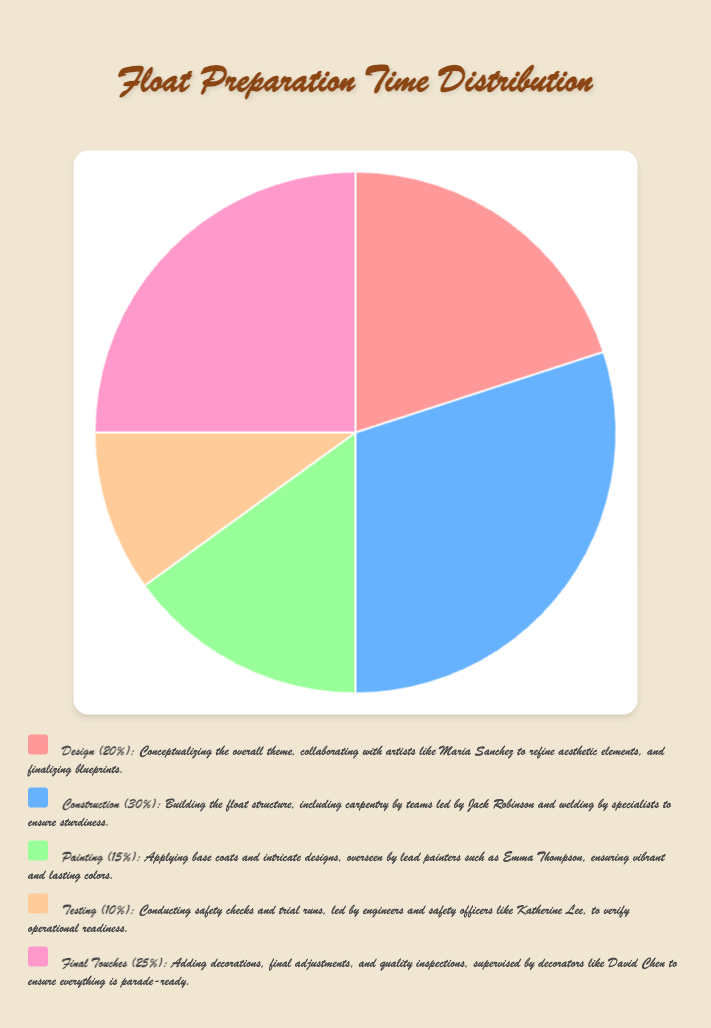What percentage of the total time is spent on Design and Final Touches combined? To get the combined percentage for Design and Final Touches, add their individual percentages: Design (20%) + Final Touches (25%). Therefore, the total is 20 + 25 = 45%.
Answer: 45% Which stage takes up the least amount of time? The stage with the lowest percentage is Testing, which accounts for 10% of the total time spent.
Answer: Testing How does the time spent on Painting compare to Testing? The percentage of time spent on Painting is 15%, while Testing takes up 10%. Painting takes more time than Testing.
Answer: Painting takes more time What is the difference in time spent between Construction and Final Touches? Construction takes 30% of the time, and Final Touches take 25%. The difference is 30 - 25 = 5%.
Answer: 5% If the total time spent on float preparation is 100 hours, how many hours are allocated to Construction? Construction takes up 30% of the total time. Therefore, it is 30% of 100 hours, which is (30/100) * 100 = 30 hours.
Answer: 30 hours What are the stages represented by the pink and blue sections in the pie chart? The pink section represents Design, and the blue section represents Construction.
Answer: Design and Construction How much more time is allocated to Design than Testing? Design takes 20% of the time, while Testing takes 10%. The difference is 20 - 10 = 10%.
Answer: 10% What is the average percentage of time spent on Construction and Painting? To find the average percentage, add the percentages of Construction (30%) and Painting (15%) and divide by 2. The average is (30 + 15) / 2 = 22.5%.
Answer: 22.5% Among the five stages, which stage’s time allocation is closest to the average of all percentages? The average percentage of all stages is (20 + 30 + 15 + 10 + 25) / 5 = 20%. The closest individual stage percentage to the average is the Design stage, which also takes 20%.
Answer: Design If an additional 5% of the total time is allocated to Testing, what will be the new percentage for Testing, and the total percentage for the other stages? Originally, Testing is 10%. If we add 5% more, it will be 10 + 5 = 15%. The total for other stages is 100 - 15 = 85%.
Answer: Testing: 15%, Others: 85% 